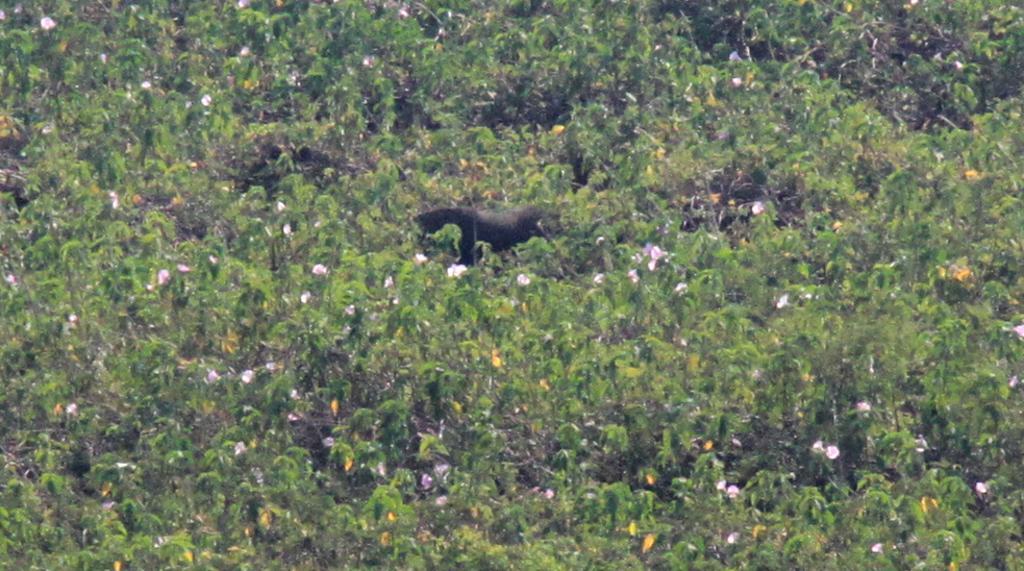Can you describe this image briefly? This image is taken outdoors. In this image there are many plants with flowers and green leaves. In the middle of the image there is a scarecrow. 